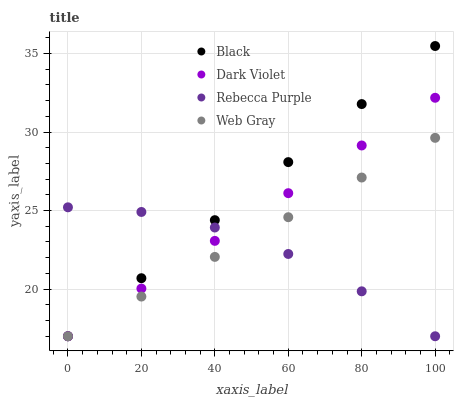Does Rebecca Purple have the minimum area under the curve?
Answer yes or no. Yes. Does Black have the maximum area under the curve?
Answer yes or no. Yes. Does Black have the minimum area under the curve?
Answer yes or no. No. Does Rebecca Purple have the maximum area under the curve?
Answer yes or no. No. Is Web Gray the smoothest?
Answer yes or no. Yes. Is Rebecca Purple the roughest?
Answer yes or no. Yes. Is Black the smoothest?
Answer yes or no. No. Is Black the roughest?
Answer yes or no. No. Does Web Gray have the lowest value?
Answer yes or no. Yes. Does Black have the highest value?
Answer yes or no. Yes. Does Rebecca Purple have the highest value?
Answer yes or no. No. Does Dark Violet intersect Black?
Answer yes or no. Yes. Is Dark Violet less than Black?
Answer yes or no. No. Is Dark Violet greater than Black?
Answer yes or no. No. 